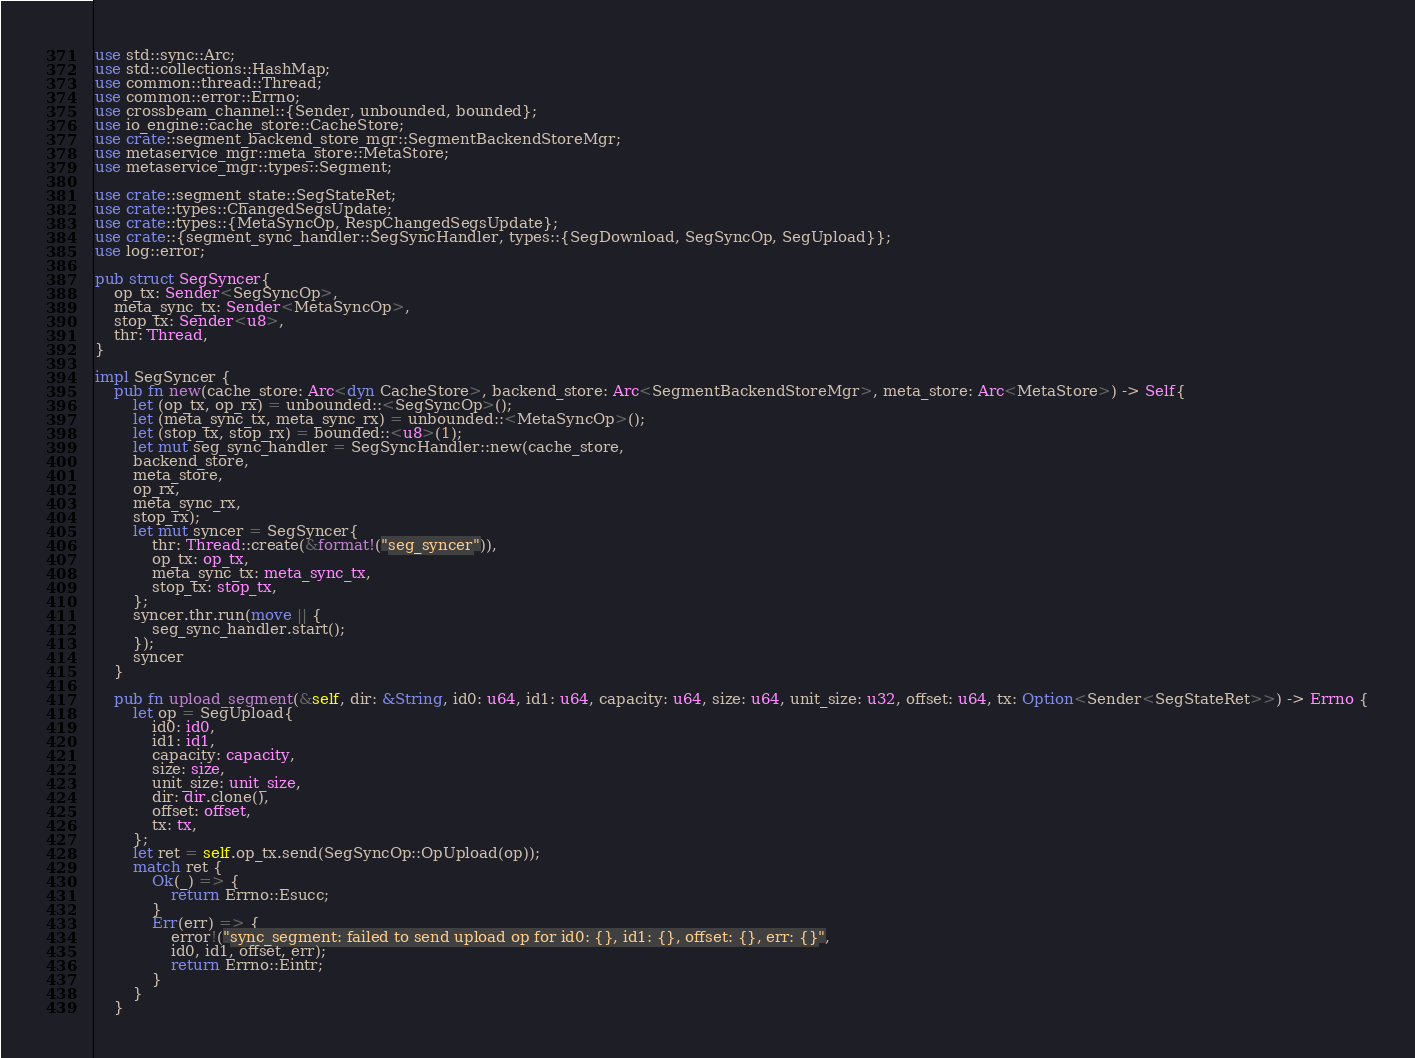<code> <loc_0><loc_0><loc_500><loc_500><_Rust_>
use std::sync::Arc;
use std::collections::HashMap;
use common::thread::Thread;
use common::error::Errno;
use crossbeam_channel::{Sender, unbounded, bounded};
use io_engine::cache_store::CacheStore;
use crate::segment_backend_store_mgr::SegmentBackendStoreMgr;
use metaservice_mgr::meta_store::MetaStore;
use metaservice_mgr::types::Segment;

use crate::segment_state::SegStateRet;
use crate::types::ChangedSegsUpdate;
use crate::types::{MetaSyncOp, RespChangedSegsUpdate};
use crate::{segment_sync_handler::SegSyncHandler, types::{SegDownload, SegSyncOp, SegUpload}};
use log::error;

pub struct SegSyncer{
    op_tx: Sender<SegSyncOp>,
    meta_sync_tx: Sender<MetaSyncOp>,
    stop_tx: Sender<u8>,
    thr: Thread,
}

impl SegSyncer {
    pub fn new(cache_store: Arc<dyn CacheStore>, backend_store: Arc<SegmentBackendStoreMgr>, meta_store: Arc<MetaStore>) -> Self{
        let (op_tx, op_rx) = unbounded::<SegSyncOp>();
        let (meta_sync_tx, meta_sync_rx) = unbounded::<MetaSyncOp>();
        let (stop_tx, stop_rx) = bounded::<u8>(1);
        let mut seg_sync_handler = SegSyncHandler::new(cache_store,
        backend_store,
        meta_store,
        op_rx,
        meta_sync_rx,
        stop_rx);
        let mut syncer = SegSyncer{
            thr: Thread::create(&format!("seg_syncer")),
            op_tx: op_tx,
            meta_sync_tx: meta_sync_tx,
            stop_tx: stop_tx,
        };
        syncer.thr.run(move || {
            seg_sync_handler.start();
        });
        syncer
    }

    pub fn upload_segment(&self, dir: &String, id0: u64, id1: u64, capacity: u64, size: u64, unit_size: u32, offset: u64, tx: Option<Sender<SegStateRet>>) -> Errno {
        let op = SegUpload{
            id0: id0,
            id1: id1,
            capacity: capacity,
            size: size,
            unit_size: unit_size,
            dir: dir.clone(),
            offset: offset,
            tx: tx,
        };
        let ret = self.op_tx.send(SegSyncOp::OpUpload(op));
        match ret {
            Ok(_) => {
                return Errno::Esucc;
            }
            Err(err) => {
                error!("sync_segment: failed to send upload op for id0: {}, id1: {}, offset: {}, err: {}",
                id0, id1, offset, err);
                return Errno::Eintr;
            }
        }
    }
</code> 